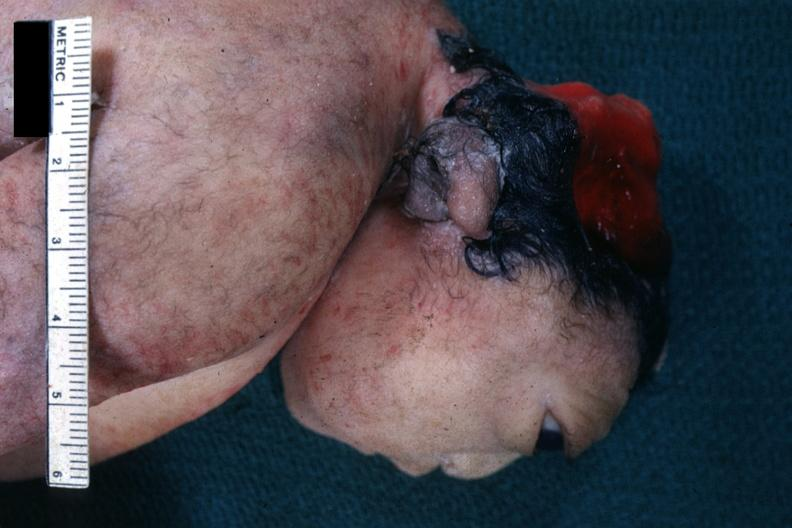what is present?
Answer the question using a single word or phrase. Anencephaly 